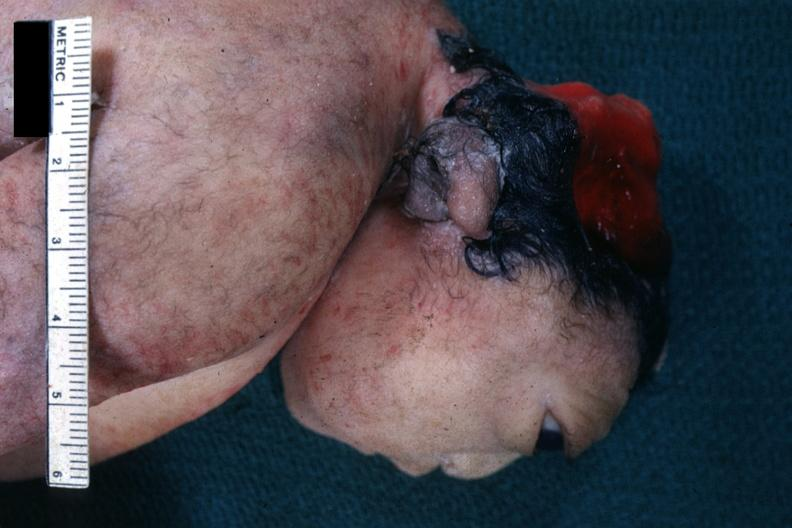what is present?
Answer the question using a single word or phrase. Anencephaly 